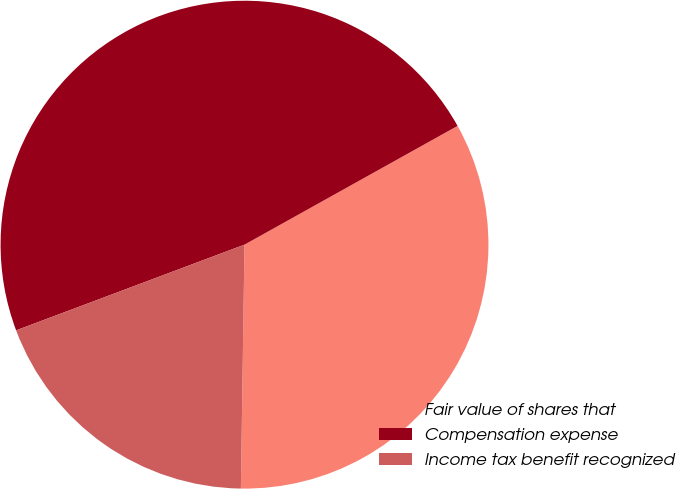Convert chart to OTSL. <chart><loc_0><loc_0><loc_500><loc_500><pie_chart><fcel>Fair value of shares that<fcel>Compensation expense<fcel>Income tax benefit recognized<nl><fcel>33.33%<fcel>47.62%<fcel>19.05%<nl></chart> 